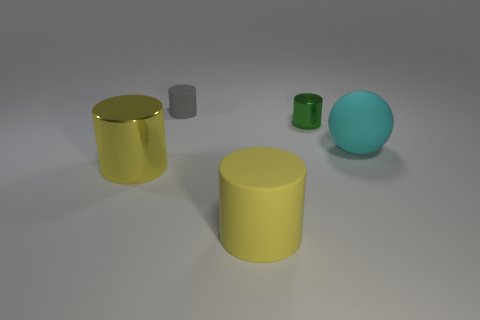Do the green cylinder and the big cyan ball have the same material?
Keep it short and to the point. No. There is another shiny object that is the same shape as the green metal object; what size is it?
Make the answer very short. Large. How many things are cylinders in front of the gray object or things left of the large cyan thing?
Your answer should be compact. 4. Is the number of large brown metal objects less than the number of tiny shiny things?
Make the answer very short. Yes. There is a gray cylinder; is it the same size as the matte cylinder in front of the big cyan object?
Offer a terse response. No. What number of matte objects are yellow objects or tiny cylinders?
Offer a terse response. 2. Is the number of small things greater than the number of cylinders?
Make the answer very short. No. What size is the shiny cylinder that is the same color as the big rubber cylinder?
Provide a short and direct response. Large. The big yellow object left of the large rubber thing that is in front of the big cyan rubber object is what shape?
Keep it short and to the point. Cylinder. There is a cylinder right of the big yellow cylinder that is in front of the big shiny thing; are there any matte spheres in front of it?
Offer a very short reply. Yes. 